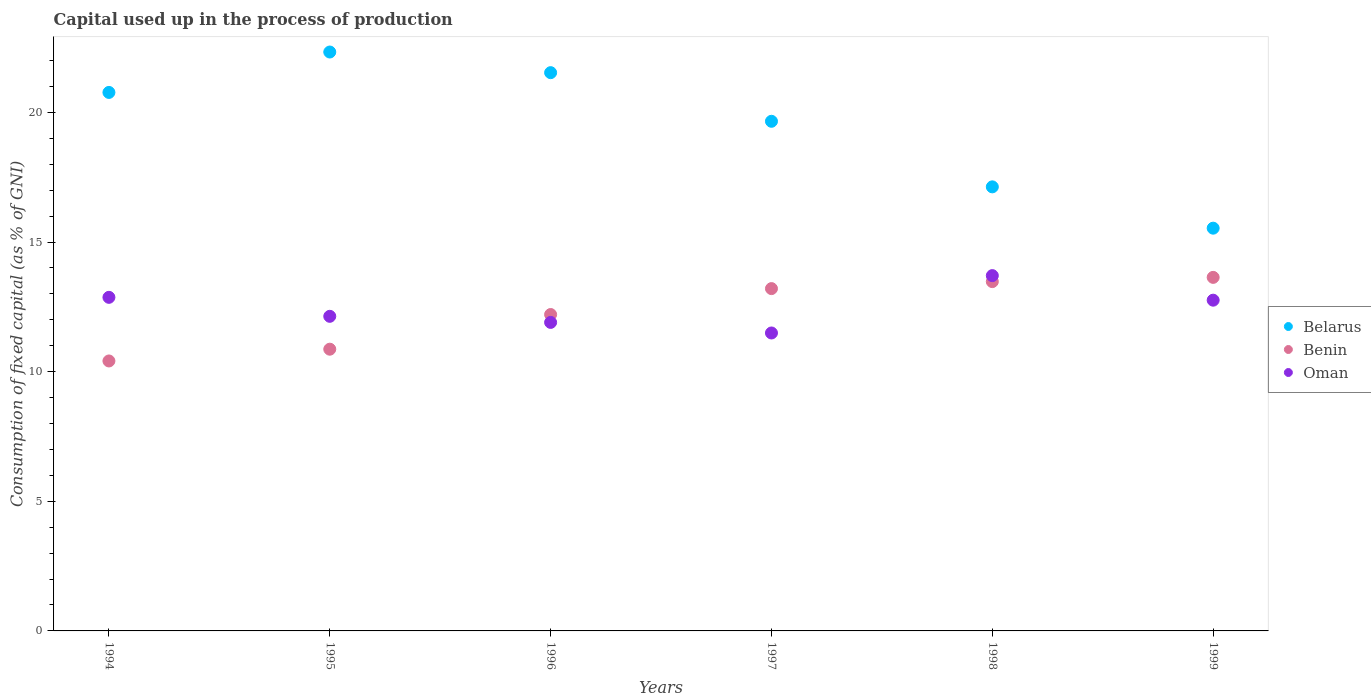What is the capital used up in the process of production in Oman in 1999?
Ensure brevity in your answer.  12.76. Across all years, what is the maximum capital used up in the process of production in Benin?
Keep it short and to the point. 13.64. Across all years, what is the minimum capital used up in the process of production in Belarus?
Offer a terse response. 15.53. In which year was the capital used up in the process of production in Oman maximum?
Your answer should be very brief. 1998. In which year was the capital used up in the process of production in Benin minimum?
Make the answer very short. 1994. What is the total capital used up in the process of production in Belarus in the graph?
Provide a short and direct response. 116.95. What is the difference between the capital used up in the process of production in Belarus in 1994 and that in 1997?
Your response must be concise. 1.11. What is the difference between the capital used up in the process of production in Oman in 1998 and the capital used up in the process of production in Benin in 1996?
Offer a very short reply. 1.5. What is the average capital used up in the process of production in Benin per year?
Offer a very short reply. 12.3. In the year 1994, what is the difference between the capital used up in the process of production in Belarus and capital used up in the process of production in Oman?
Keep it short and to the point. 7.9. What is the ratio of the capital used up in the process of production in Belarus in 1995 to that in 1999?
Provide a short and direct response. 1.44. Is the capital used up in the process of production in Belarus in 1998 less than that in 1999?
Give a very brief answer. No. What is the difference between the highest and the second highest capital used up in the process of production in Benin?
Provide a short and direct response. 0.16. What is the difference between the highest and the lowest capital used up in the process of production in Belarus?
Make the answer very short. 6.79. In how many years, is the capital used up in the process of production in Benin greater than the average capital used up in the process of production in Benin taken over all years?
Your answer should be very brief. 3. Is the sum of the capital used up in the process of production in Belarus in 1995 and 1997 greater than the maximum capital used up in the process of production in Oman across all years?
Offer a very short reply. Yes. Is it the case that in every year, the sum of the capital used up in the process of production in Belarus and capital used up in the process of production in Benin  is greater than the capital used up in the process of production in Oman?
Give a very brief answer. Yes. Does the capital used up in the process of production in Belarus monotonically increase over the years?
Your answer should be very brief. No. Is the capital used up in the process of production in Benin strictly greater than the capital used up in the process of production in Belarus over the years?
Provide a short and direct response. No. Is the capital used up in the process of production in Belarus strictly less than the capital used up in the process of production in Benin over the years?
Keep it short and to the point. No. How many years are there in the graph?
Offer a terse response. 6. What is the difference between two consecutive major ticks on the Y-axis?
Your answer should be compact. 5. Are the values on the major ticks of Y-axis written in scientific E-notation?
Offer a very short reply. No. Does the graph contain any zero values?
Offer a terse response. No. How are the legend labels stacked?
Your answer should be compact. Vertical. What is the title of the graph?
Give a very brief answer. Capital used up in the process of production. What is the label or title of the Y-axis?
Provide a succinct answer. Consumption of fixed capital (as % of GNI). What is the Consumption of fixed capital (as % of GNI) in Belarus in 1994?
Keep it short and to the point. 20.77. What is the Consumption of fixed capital (as % of GNI) of Benin in 1994?
Keep it short and to the point. 10.41. What is the Consumption of fixed capital (as % of GNI) in Oman in 1994?
Give a very brief answer. 12.87. What is the Consumption of fixed capital (as % of GNI) in Belarus in 1995?
Your answer should be compact. 22.33. What is the Consumption of fixed capital (as % of GNI) in Benin in 1995?
Ensure brevity in your answer.  10.87. What is the Consumption of fixed capital (as % of GNI) in Oman in 1995?
Offer a terse response. 12.13. What is the Consumption of fixed capital (as % of GNI) in Belarus in 1996?
Your response must be concise. 21.53. What is the Consumption of fixed capital (as % of GNI) in Benin in 1996?
Your answer should be compact. 12.2. What is the Consumption of fixed capital (as % of GNI) of Oman in 1996?
Provide a succinct answer. 11.9. What is the Consumption of fixed capital (as % of GNI) in Belarus in 1997?
Your answer should be very brief. 19.66. What is the Consumption of fixed capital (as % of GNI) of Benin in 1997?
Your answer should be very brief. 13.2. What is the Consumption of fixed capital (as % of GNI) in Oman in 1997?
Your answer should be very brief. 11.49. What is the Consumption of fixed capital (as % of GNI) in Belarus in 1998?
Offer a terse response. 17.13. What is the Consumption of fixed capital (as % of GNI) in Benin in 1998?
Ensure brevity in your answer.  13.47. What is the Consumption of fixed capital (as % of GNI) of Oman in 1998?
Make the answer very short. 13.7. What is the Consumption of fixed capital (as % of GNI) in Belarus in 1999?
Keep it short and to the point. 15.53. What is the Consumption of fixed capital (as % of GNI) of Benin in 1999?
Provide a succinct answer. 13.64. What is the Consumption of fixed capital (as % of GNI) of Oman in 1999?
Ensure brevity in your answer.  12.76. Across all years, what is the maximum Consumption of fixed capital (as % of GNI) of Belarus?
Provide a succinct answer. 22.33. Across all years, what is the maximum Consumption of fixed capital (as % of GNI) of Benin?
Offer a terse response. 13.64. Across all years, what is the maximum Consumption of fixed capital (as % of GNI) in Oman?
Offer a terse response. 13.7. Across all years, what is the minimum Consumption of fixed capital (as % of GNI) in Belarus?
Make the answer very short. 15.53. Across all years, what is the minimum Consumption of fixed capital (as % of GNI) in Benin?
Make the answer very short. 10.41. Across all years, what is the minimum Consumption of fixed capital (as % of GNI) of Oman?
Ensure brevity in your answer.  11.49. What is the total Consumption of fixed capital (as % of GNI) of Belarus in the graph?
Provide a short and direct response. 116.95. What is the total Consumption of fixed capital (as % of GNI) of Benin in the graph?
Ensure brevity in your answer.  73.79. What is the total Consumption of fixed capital (as % of GNI) of Oman in the graph?
Your answer should be compact. 74.85. What is the difference between the Consumption of fixed capital (as % of GNI) in Belarus in 1994 and that in 1995?
Make the answer very short. -1.56. What is the difference between the Consumption of fixed capital (as % of GNI) in Benin in 1994 and that in 1995?
Provide a short and direct response. -0.45. What is the difference between the Consumption of fixed capital (as % of GNI) of Oman in 1994 and that in 1995?
Provide a short and direct response. 0.73. What is the difference between the Consumption of fixed capital (as % of GNI) of Belarus in 1994 and that in 1996?
Offer a very short reply. -0.76. What is the difference between the Consumption of fixed capital (as % of GNI) in Benin in 1994 and that in 1996?
Provide a short and direct response. -1.79. What is the difference between the Consumption of fixed capital (as % of GNI) of Oman in 1994 and that in 1996?
Your answer should be compact. 0.97. What is the difference between the Consumption of fixed capital (as % of GNI) of Belarus in 1994 and that in 1997?
Your response must be concise. 1.11. What is the difference between the Consumption of fixed capital (as % of GNI) of Benin in 1994 and that in 1997?
Ensure brevity in your answer.  -2.79. What is the difference between the Consumption of fixed capital (as % of GNI) in Oman in 1994 and that in 1997?
Offer a very short reply. 1.37. What is the difference between the Consumption of fixed capital (as % of GNI) of Belarus in 1994 and that in 1998?
Your answer should be compact. 3.64. What is the difference between the Consumption of fixed capital (as % of GNI) in Benin in 1994 and that in 1998?
Make the answer very short. -3.06. What is the difference between the Consumption of fixed capital (as % of GNI) of Oman in 1994 and that in 1998?
Your answer should be compact. -0.84. What is the difference between the Consumption of fixed capital (as % of GNI) of Belarus in 1994 and that in 1999?
Offer a terse response. 5.24. What is the difference between the Consumption of fixed capital (as % of GNI) in Benin in 1994 and that in 1999?
Give a very brief answer. -3.22. What is the difference between the Consumption of fixed capital (as % of GNI) of Oman in 1994 and that in 1999?
Provide a succinct answer. 0.11. What is the difference between the Consumption of fixed capital (as % of GNI) in Belarus in 1995 and that in 1996?
Your answer should be compact. 0.8. What is the difference between the Consumption of fixed capital (as % of GNI) in Benin in 1995 and that in 1996?
Your response must be concise. -1.34. What is the difference between the Consumption of fixed capital (as % of GNI) in Oman in 1995 and that in 1996?
Offer a terse response. 0.23. What is the difference between the Consumption of fixed capital (as % of GNI) in Belarus in 1995 and that in 1997?
Keep it short and to the point. 2.67. What is the difference between the Consumption of fixed capital (as % of GNI) in Benin in 1995 and that in 1997?
Provide a short and direct response. -2.34. What is the difference between the Consumption of fixed capital (as % of GNI) of Oman in 1995 and that in 1997?
Your response must be concise. 0.64. What is the difference between the Consumption of fixed capital (as % of GNI) of Belarus in 1995 and that in 1998?
Offer a terse response. 5.2. What is the difference between the Consumption of fixed capital (as % of GNI) in Benin in 1995 and that in 1998?
Your answer should be very brief. -2.61. What is the difference between the Consumption of fixed capital (as % of GNI) in Oman in 1995 and that in 1998?
Ensure brevity in your answer.  -1.57. What is the difference between the Consumption of fixed capital (as % of GNI) in Belarus in 1995 and that in 1999?
Give a very brief answer. 6.79. What is the difference between the Consumption of fixed capital (as % of GNI) of Benin in 1995 and that in 1999?
Ensure brevity in your answer.  -2.77. What is the difference between the Consumption of fixed capital (as % of GNI) in Oman in 1995 and that in 1999?
Provide a short and direct response. -0.62. What is the difference between the Consumption of fixed capital (as % of GNI) of Belarus in 1996 and that in 1997?
Your answer should be very brief. 1.88. What is the difference between the Consumption of fixed capital (as % of GNI) in Benin in 1996 and that in 1997?
Make the answer very short. -1. What is the difference between the Consumption of fixed capital (as % of GNI) in Oman in 1996 and that in 1997?
Provide a short and direct response. 0.41. What is the difference between the Consumption of fixed capital (as % of GNI) in Belarus in 1996 and that in 1998?
Make the answer very short. 4.4. What is the difference between the Consumption of fixed capital (as % of GNI) in Benin in 1996 and that in 1998?
Your answer should be compact. -1.27. What is the difference between the Consumption of fixed capital (as % of GNI) of Oman in 1996 and that in 1998?
Keep it short and to the point. -1.8. What is the difference between the Consumption of fixed capital (as % of GNI) in Belarus in 1996 and that in 1999?
Offer a terse response. 6. What is the difference between the Consumption of fixed capital (as % of GNI) of Benin in 1996 and that in 1999?
Your answer should be very brief. -1.43. What is the difference between the Consumption of fixed capital (as % of GNI) of Oman in 1996 and that in 1999?
Give a very brief answer. -0.86. What is the difference between the Consumption of fixed capital (as % of GNI) of Belarus in 1997 and that in 1998?
Your answer should be very brief. 2.53. What is the difference between the Consumption of fixed capital (as % of GNI) in Benin in 1997 and that in 1998?
Provide a succinct answer. -0.27. What is the difference between the Consumption of fixed capital (as % of GNI) in Oman in 1997 and that in 1998?
Your answer should be compact. -2.21. What is the difference between the Consumption of fixed capital (as % of GNI) of Belarus in 1997 and that in 1999?
Give a very brief answer. 4.12. What is the difference between the Consumption of fixed capital (as % of GNI) of Benin in 1997 and that in 1999?
Your response must be concise. -0.43. What is the difference between the Consumption of fixed capital (as % of GNI) of Oman in 1997 and that in 1999?
Offer a very short reply. -1.26. What is the difference between the Consumption of fixed capital (as % of GNI) in Belarus in 1998 and that in 1999?
Offer a very short reply. 1.59. What is the difference between the Consumption of fixed capital (as % of GNI) in Benin in 1998 and that in 1999?
Ensure brevity in your answer.  -0.16. What is the difference between the Consumption of fixed capital (as % of GNI) of Oman in 1998 and that in 1999?
Make the answer very short. 0.95. What is the difference between the Consumption of fixed capital (as % of GNI) of Belarus in 1994 and the Consumption of fixed capital (as % of GNI) of Benin in 1995?
Provide a short and direct response. 9.9. What is the difference between the Consumption of fixed capital (as % of GNI) of Belarus in 1994 and the Consumption of fixed capital (as % of GNI) of Oman in 1995?
Provide a short and direct response. 8.64. What is the difference between the Consumption of fixed capital (as % of GNI) of Benin in 1994 and the Consumption of fixed capital (as % of GNI) of Oman in 1995?
Keep it short and to the point. -1.72. What is the difference between the Consumption of fixed capital (as % of GNI) of Belarus in 1994 and the Consumption of fixed capital (as % of GNI) of Benin in 1996?
Your response must be concise. 8.57. What is the difference between the Consumption of fixed capital (as % of GNI) in Belarus in 1994 and the Consumption of fixed capital (as % of GNI) in Oman in 1996?
Make the answer very short. 8.87. What is the difference between the Consumption of fixed capital (as % of GNI) of Benin in 1994 and the Consumption of fixed capital (as % of GNI) of Oman in 1996?
Provide a short and direct response. -1.49. What is the difference between the Consumption of fixed capital (as % of GNI) of Belarus in 1994 and the Consumption of fixed capital (as % of GNI) of Benin in 1997?
Your answer should be compact. 7.57. What is the difference between the Consumption of fixed capital (as % of GNI) in Belarus in 1994 and the Consumption of fixed capital (as % of GNI) in Oman in 1997?
Keep it short and to the point. 9.28. What is the difference between the Consumption of fixed capital (as % of GNI) in Benin in 1994 and the Consumption of fixed capital (as % of GNI) in Oman in 1997?
Your answer should be compact. -1.08. What is the difference between the Consumption of fixed capital (as % of GNI) in Belarus in 1994 and the Consumption of fixed capital (as % of GNI) in Benin in 1998?
Your answer should be very brief. 7.3. What is the difference between the Consumption of fixed capital (as % of GNI) in Belarus in 1994 and the Consumption of fixed capital (as % of GNI) in Oman in 1998?
Provide a short and direct response. 7.07. What is the difference between the Consumption of fixed capital (as % of GNI) in Benin in 1994 and the Consumption of fixed capital (as % of GNI) in Oman in 1998?
Offer a terse response. -3.29. What is the difference between the Consumption of fixed capital (as % of GNI) of Belarus in 1994 and the Consumption of fixed capital (as % of GNI) of Benin in 1999?
Provide a succinct answer. 7.13. What is the difference between the Consumption of fixed capital (as % of GNI) in Belarus in 1994 and the Consumption of fixed capital (as % of GNI) in Oman in 1999?
Offer a very short reply. 8.01. What is the difference between the Consumption of fixed capital (as % of GNI) in Benin in 1994 and the Consumption of fixed capital (as % of GNI) in Oman in 1999?
Provide a short and direct response. -2.34. What is the difference between the Consumption of fixed capital (as % of GNI) of Belarus in 1995 and the Consumption of fixed capital (as % of GNI) of Benin in 1996?
Make the answer very short. 10.12. What is the difference between the Consumption of fixed capital (as % of GNI) of Belarus in 1995 and the Consumption of fixed capital (as % of GNI) of Oman in 1996?
Provide a short and direct response. 10.43. What is the difference between the Consumption of fixed capital (as % of GNI) of Benin in 1995 and the Consumption of fixed capital (as % of GNI) of Oman in 1996?
Your response must be concise. -1.03. What is the difference between the Consumption of fixed capital (as % of GNI) in Belarus in 1995 and the Consumption of fixed capital (as % of GNI) in Benin in 1997?
Keep it short and to the point. 9.13. What is the difference between the Consumption of fixed capital (as % of GNI) of Belarus in 1995 and the Consumption of fixed capital (as % of GNI) of Oman in 1997?
Give a very brief answer. 10.84. What is the difference between the Consumption of fixed capital (as % of GNI) of Benin in 1995 and the Consumption of fixed capital (as % of GNI) of Oman in 1997?
Make the answer very short. -0.63. What is the difference between the Consumption of fixed capital (as % of GNI) of Belarus in 1995 and the Consumption of fixed capital (as % of GNI) of Benin in 1998?
Your answer should be very brief. 8.86. What is the difference between the Consumption of fixed capital (as % of GNI) of Belarus in 1995 and the Consumption of fixed capital (as % of GNI) of Oman in 1998?
Make the answer very short. 8.62. What is the difference between the Consumption of fixed capital (as % of GNI) in Benin in 1995 and the Consumption of fixed capital (as % of GNI) in Oman in 1998?
Your answer should be compact. -2.84. What is the difference between the Consumption of fixed capital (as % of GNI) in Belarus in 1995 and the Consumption of fixed capital (as % of GNI) in Benin in 1999?
Your response must be concise. 8.69. What is the difference between the Consumption of fixed capital (as % of GNI) of Belarus in 1995 and the Consumption of fixed capital (as % of GNI) of Oman in 1999?
Provide a short and direct response. 9.57. What is the difference between the Consumption of fixed capital (as % of GNI) of Benin in 1995 and the Consumption of fixed capital (as % of GNI) of Oman in 1999?
Ensure brevity in your answer.  -1.89. What is the difference between the Consumption of fixed capital (as % of GNI) in Belarus in 1996 and the Consumption of fixed capital (as % of GNI) in Benin in 1997?
Ensure brevity in your answer.  8.33. What is the difference between the Consumption of fixed capital (as % of GNI) in Belarus in 1996 and the Consumption of fixed capital (as % of GNI) in Oman in 1997?
Provide a succinct answer. 10.04. What is the difference between the Consumption of fixed capital (as % of GNI) in Benin in 1996 and the Consumption of fixed capital (as % of GNI) in Oman in 1997?
Ensure brevity in your answer.  0.71. What is the difference between the Consumption of fixed capital (as % of GNI) in Belarus in 1996 and the Consumption of fixed capital (as % of GNI) in Benin in 1998?
Give a very brief answer. 8.06. What is the difference between the Consumption of fixed capital (as % of GNI) of Belarus in 1996 and the Consumption of fixed capital (as % of GNI) of Oman in 1998?
Provide a short and direct response. 7.83. What is the difference between the Consumption of fixed capital (as % of GNI) of Benin in 1996 and the Consumption of fixed capital (as % of GNI) of Oman in 1998?
Ensure brevity in your answer.  -1.5. What is the difference between the Consumption of fixed capital (as % of GNI) of Belarus in 1996 and the Consumption of fixed capital (as % of GNI) of Benin in 1999?
Ensure brevity in your answer.  7.9. What is the difference between the Consumption of fixed capital (as % of GNI) in Belarus in 1996 and the Consumption of fixed capital (as % of GNI) in Oman in 1999?
Provide a short and direct response. 8.78. What is the difference between the Consumption of fixed capital (as % of GNI) of Benin in 1996 and the Consumption of fixed capital (as % of GNI) of Oman in 1999?
Give a very brief answer. -0.55. What is the difference between the Consumption of fixed capital (as % of GNI) in Belarus in 1997 and the Consumption of fixed capital (as % of GNI) in Benin in 1998?
Keep it short and to the point. 6.18. What is the difference between the Consumption of fixed capital (as % of GNI) of Belarus in 1997 and the Consumption of fixed capital (as % of GNI) of Oman in 1998?
Give a very brief answer. 5.95. What is the difference between the Consumption of fixed capital (as % of GNI) in Benin in 1997 and the Consumption of fixed capital (as % of GNI) in Oman in 1998?
Give a very brief answer. -0.5. What is the difference between the Consumption of fixed capital (as % of GNI) in Belarus in 1997 and the Consumption of fixed capital (as % of GNI) in Benin in 1999?
Keep it short and to the point. 6.02. What is the difference between the Consumption of fixed capital (as % of GNI) of Benin in 1997 and the Consumption of fixed capital (as % of GNI) of Oman in 1999?
Your answer should be compact. 0.45. What is the difference between the Consumption of fixed capital (as % of GNI) in Belarus in 1998 and the Consumption of fixed capital (as % of GNI) in Benin in 1999?
Offer a terse response. 3.49. What is the difference between the Consumption of fixed capital (as % of GNI) in Belarus in 1998 and the Consumption of fixed capital (as % of GNI) in Oman in 1999?
Provide a short and direct response. 4.37. What is the difference between the Consumption of fixed capital (as % of GNI) of Benin in 1998 and the Consumption of fixed capital (as % of GNI) of Oman in 1999?
Your response must be concise. 0.72. What is the average Consumption of fixed capital (as % of GNI) in Belarus per year?
Your response must be concise. 19.49. What is the average Consumption of fixed capital (as % of GNI) in Benin per year?
Provide a short and direct response. 12.3. What is the average Consumption of fixed capital (as % of GNI) of Oman per year?
Your answer should be very brief. 12.48. In the year 1994, what is the difference between the Consumption of fixed capital (as % of GNI) of Belarus and Consumption of fixed capital (as % of GNI) of Benin?
Your answer should be compact. 10.36. In the year 1994, what is the difference between the Consumption of fixed capital (as % of GNI) in Belarus and Consumption of fixed capital (as % of GNI) in Oman?
Make the answer very short. 7.9. In the year 1994, what is the difference between the Consumption of fixed capital (as % of GNI) in Benin and Consumption of fixed capital (as % of GNI) in Oman?
Ensure brevity in your answer.  -2.45. In the year 1995, what is the difference between the Consumption of fixed capital (as % of GNI) of Belarus and Consumption of fixed capital (as % of GNI) of Benin?
Provide a succinct answer. 11.46. In the year 1995, what is the difference between the Consumption of fixed capital (as % of GNI) of Belarus and Consumption of fixed capital (as % of GNI) of Oman?
Provide a succinct answer. 10.19. In the year 1995, what is the difference between the Consumption of fixed capital (as % of GNI) in Benin and Consumption of fixed capital (as % of GNI) in Oman?
Provide a succinct answer. -1.27. In the year 1996, what is the difference between the Consumption of fixed capital (as % of GNI) in Belarus and Consumption of fixed capital (as % of GNI) in Benin?
Keep it short and to the point. 9.33. In the year 1996, what is the difference between the Consumption of fixed capital (as % of GNI) of Belarus and Consumption of fixed capital (as % of GNI) of Oman?
Your answer should be very brief. 9.63. In the year 1996, what is the difference between the Consumption of fixed capital (as % of GNI) of Benin and Consumption of fixed capital (as % of GNI) of Oman?
Your response must be concise. 0.3. In the year 1997, what is the difference between the Consumption of fixed capital (as % of GNI) in Belarus and Consumption of fixed capital (as % of GNI) in Benin?
Offer a terse response. 6.45. In the year 1997, what is the difference between the Consumption of fixed capital (as % of GNI) in Belarus and Consumption of fixed capital (as % of GNI) in Oman?
Ensure brevity in your answer.  8.16. In the year 1997, what is the difference between the Consumption of fixed capital (as % of GNI) in Benin and Consumption of fixed capital (as % of GNI) in Oman?
Your response must be concise. 1.71. In the year 1998, what is the difference between the Consumption of fixed capital (as % of GNI) of Belarus and Consumption of fixed capital (as % of GNI) of Benin?
Make the answer very short. 3.65. In the year 1998, what is the difference between the Consumption of fixed capital (as % of GNI) of Belarus and Consumption of fixed capital (as % of GNI) of Oman?
Provide a succinct answer. 3.42. In the year 1998, what is the difference between the Consumption of fixed capital (as % of GNI) in Benin and Consumption of fixed capital (as % of GNI) in Oman?
Your answer should be compact. -0.23. In the year 1999, what is the difference between the Consumption of fixed capital (as % of GNI) in Belarus and Consumption of fixed capital (as % of GNI) in Benin?
Ensure brevity in your answer.  1.9. In the year 1999, what is the difference between the Consumption of fixed capital (as % of GNI) in Belarus and Consumption of fixed capital (as % of GNI) in Oman?
Keep it short and to the point. 2.78. In the year 1999, what is the difference between the Consumption of fixed capital (as % of GNI) of Benin and Consumption of fixed capital (as % of GNI) of Oman?
Offer a very short reply. 0.88. What is the ratio of the Consumption of fixed capital (as % of GNI) of Belarus in 1994 to that in 1995?
Provide a succinct answer. 0.93. What is the ratio of the Consumption of fixed capital (as % of GNI) in Benin in 1994 to that in 1995?
Offer a terse response. 0.96. What is the ratio of the Consumption of fixed capital (as % of GNI) in Oman in 1994 to that in 1995?
Your response must be concise. 1.06. What is the ratio of the Consumption of fixed capital (as % of GNI) of Belarus in 1994 to that in 1996?
Your answer should be very brief. 0.96. What is the ratio of the Consumption of fixed capital (as % of GNI) of Benin in 1994 to that in 1996?
Your answer should be compact. 0.85. What is the ratio of the Consumption of fixed capital (as % of GNI) of Oman in 1994 to that in 1996?
Keep it short and to the point. 1.08. What is the ratio of the Consumption of fixed capital (as % of GNI) in Belarus in 1994 to that in 1997?
Offer a very short reply. 1.06. What is the ratio of the Consumption of fixed capital (as % of GNI) in Benin in 1994 to that in 1997?
Your response must be concise. 0.79. What is the ratio of the Consumption of fixed capital (as % of GNI) of Oman in 1994 to that in 1997?
Give a very brief answer. 1.12. What is the ratio of the Consumption of fixed capital (as % of GNI) of Belarus in 1994 to that in 1998?
Your answer should be very brief. 1.21. What is the ratio of the Consumption of fixed capital (as % of GNI) of Benin in 1994 to that in 1998?
Offer a very short reply. 0.77. What is the ratio of the Consumption of fixed capital (as % of GNI) of Oman in 1994 to that in 1998?
Your answer should be very brief. 0.94. What is the ratio of the Consumption of fixed capital (as % of GNI) in Belarus in 1994 to that in 1999?
Give a very brief answer. 1.34. What is the ratio of the Consumption of fixed capital (as % of GNI) in Benin in 1994 to that in 1999?
Offer a terse response. 0.76. What is the ratio of the Consumption of fixed capital (as % of GNI) of Oman in 1994 to that in 1999?
Ensure brevity in your answer.  1.01. What is the ratio of the Consumption of fixed capital (as % of GNI) in Benin in 1995 to that in 1996?
Ensure brevity in your answer.  0.89. What is the ratio of the Consumption of fixed capital (as % of GNI) of Oman in 1995 to that in 1996?
Give a very brief answer. 1.02. What is the ratio of the Consumption of fixed capital (as % of GNI) in Belarus in 1995 to that in 1997?
Offer a very short reply. 1.14. What is the ratio of the Consumption of fixed capital (as % of GNI) of Benin in 1995 to that in 1997?
Make the answer very short. 0.82. What is the ratio of the Consumption of fixed capital (as % of GNI) in Oman in 1995 to that in 1997?
Your response must be concise. 1.06. What is the ratio of the Consumption of fixed capital (as % of GNI) in Belarus in 1995 to that in 1998?
Offer a very short reply. 1.3. What is the ratio of the Consumption of fixed capital (as % of GNI) in Benin in 1995 to that in 1998?
Your response must be concise. 0.81. What is the ratio of the Consumption of fixed capital (as % of GNI) of Oman in 1995 to that in 1998?
Offer a terse response. 0.89. What is the ratio of the Consumption of fixed capital (as % of GNI) of Belarus in 1995 to that in 1999?
Make the answer very short. 1.44. What is the ratio of the Consumption of fixed capital (as % of GNI) in Benin in 1995 to that in 1999?
Make the answer very short. 0.8. What is the ratio of the Consumption of fixed capital (as % of GNI) of Oman in 1995 to that in 1999?
Ensure brevity in your answer.  0.95. What is the ratio of the Consumption of fixed capital (as % of GNI) in Belarus in 1996 to that in 1997?
Ensure brevity in your answer.  1.1. What is the ratio of the Consumption of fixed capital (as % of GNI) in Benin in 1996 to that in 1997?
Your answer should be very brief. 0.92. What is the ratio of the Consumption of fixed capital (as % of GNI) of Oman in 1996 to that in 1997?
Your answer should be compact. 1.04. What is the ratio of the Consumption of fixed capital (as % of GNI) of Belarus in 1996 to that in 1998?
Provide a short and direct response. 1.26. What is the ratio of the Consumption of fixed capital (as % of GNI) of Benin in 1996 to that in 1998?
Provide a short and direct response. 0.91. What is the ratio of the Consumption of fixed capital (as % of GNI) of Oman in 1996 to that in 1998?
Your answer should be very brief. 0.87. What is the ratio of the Consumption of fixed capital (as % of GNI) of Belarus in 1996 to that in 1999?
Give a very brief answer. 1.39. What is the ratio of the Consumption of fixed capital (as % of GNI) in Benin in 1996 to that in 1999?
Your answer should be very brief. 0.89. What is the ratio of the Consumption of fixed capital (as % of GNI) in Oman in 1996 to that in 1999?
Offer a terse response. 0.93. What is the ratio of the Consumption of fixed capital (as % of GNI) in Belarus in 1997 to that in 1998?
Offer a terse response. 1.15. What is the ratio of the Consumption of fixed capital (as % of GNI) in Oman in 1997 to that in 1998?
Your answer should be very brief. 0.84. What is the ratio of the Consumption of fixed capital (as % of GNI) of Belarus in 1997 to that in 1999?
Your answer should be compact. 1.27. What is the ratio of the Consumption of fixed capital (as % of GNI) of Benin in 1997 to that in 1999?
Your answer should be very brief. 0.97. What is the ratio of the Consumption of fixed capital (as % of GNI) of Oman in 1997 to that in 1999?
Keep it short and to the point. 0.9. What is the ratio of the Consumption of fixed capital (as % of GNI) in Belarus in 1998 to that in 1999?
Offer a terse response. 1.1. What is the ratio of the Consumption of fixed capital (as % of GNI) in Benin in 1998 to that in 1999?
Give a very brief answer. 0.99. What is the ratio of the Consumption of fixed capital (as % of GNI) of Oman in 1998 to that in 1999?
Provide a short and direct response. 1.07. What is the difference between the highest and the second highest Consumption of fixed capital (as % of GNI) in Belarus?
Your answer should be compact. 0.8. What is the difference between the highest and the second highest Consumption of fixed capital (as % of GNI) of Benin?
Ensure brevity in your answer.  0.16. What is the difference between the highest and the second highest Consumption of fixed capital (as % of GNI) in Oman?
Give a very brief answer. 0.84. What is the difference between the highest and the lowest Consumption of fixed capital (as % of GNI) in Belarus?
Offer a terse response. 6.79. What is the difference between the highest and the lowest Consumption of fixed capital (as % of GNI) of Benin?
Give a very brief answer. 3.22. What is the difference between the highest and the lowest Consumption of fixed capital (as % of GNI) of Oman?
Your answer should be compact. 2.21. 